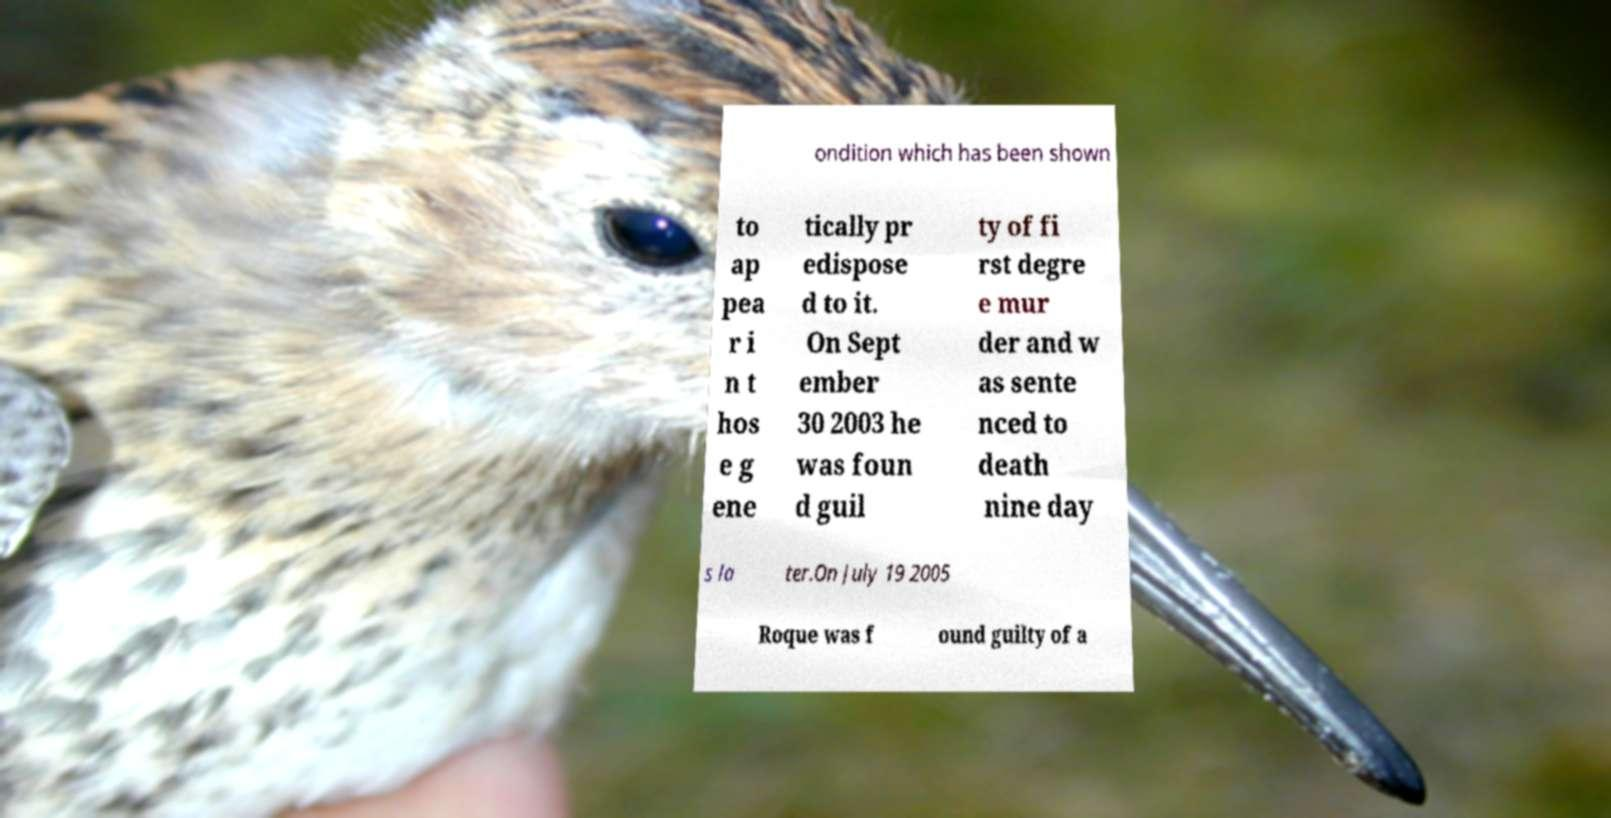Please identify and transcribe the text found in this image. ondition which has been shown to ap pea r i n t hos e g ene tically pr edispose d to it. On Sept ember 30 2003 he was foun d guil ty of fi rst degre e mur der and w as sente nced to death nine day s la ter.On July 19 2005 Roque was f ound guilty of a 